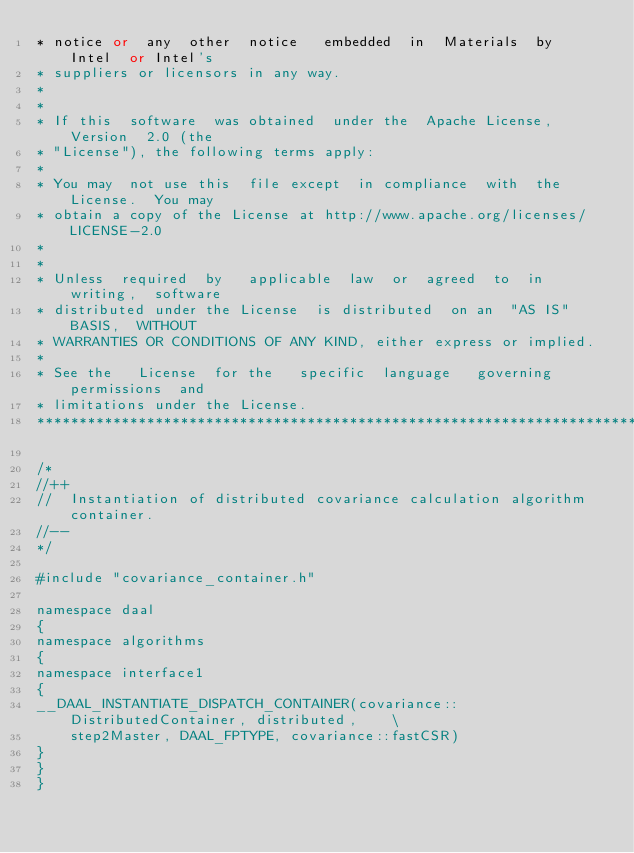<code> <loc_0><loc_0><loc_500><loc_500><_C++_>* notice or  any  other  notice   embedded  in  Materials  by  Intel  or Intel's
* suppliers or licensors in any way.
*
*
* If this  software  was obtained  under the  Apache License,  Version  2.0 (the
* "License"), the following terms apply:
*
* You may  not use this  file except  in compliance  with  the License.  You may
* obtain a copy of the License at http://www.apache.org/licenses/LICENSE-2.0
*
*
* Unless  required  by   applicable  law  or  agreed  to  in  writing,  software
* distributed under the License  is distributed  on an  "AS IS"  BASIS,  WITHOUT
* WARRANTIES OR CONDITIONS OF ANY KIND, either express or implied.
*
* See the   License  for the   specific  language   governing   permissions  and
* limitations under the License.
*******************************************************************************/

/*
//++
//  Instantiation of distributed covariance calculation algorithm container.
//--
*/

#include "covariance_container.h"

namespace daal
{
namespace algorithms
{
namespace interface1
{
__DAAL_INSTANTIATE_DISPATCH_CONTAINER(covariance::DistributedContainer, distributed,    \
    step2Master, DAAL_FPTYPE, covariance::fastCSR)
}
}
}
</code> 